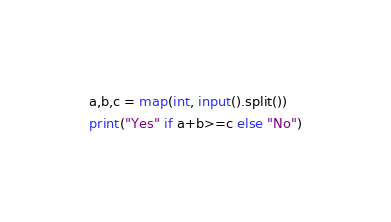<code> <loc_0><loc_0><loc_500><loc_500><_Python_>a,b,c = map(int, input().split())
print("Yes" if a+b>=c else "No")</code> 